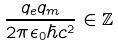Convert formula to latex. <formula><loc_0><loc_0><loc_500><loc_500>\frac { q _ { e } q _ { m } } { 2 \pi \epsilon _ { 0 } \hbar { c } ^ { 2 } } \in \mathbb { Z }</formula> 